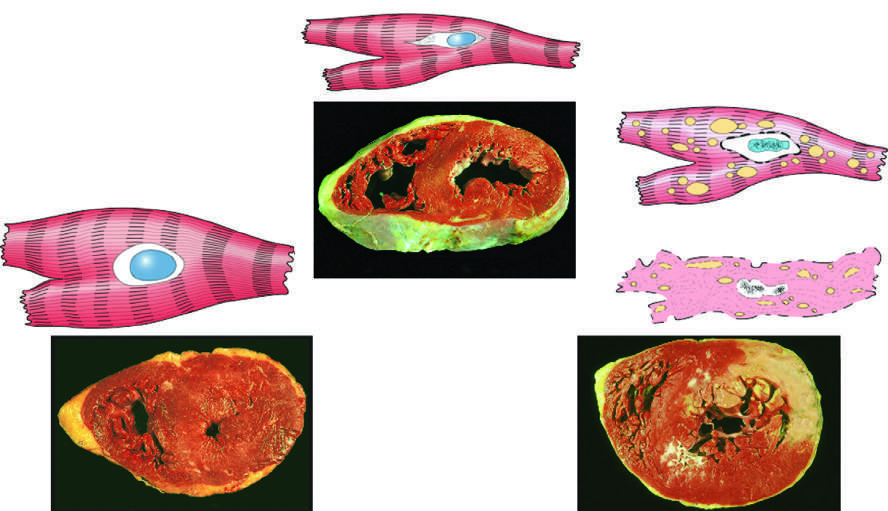does reversible injury represent an acute myocardial infarction in the specimen showing necrosis?
Answer the question using a single word or phrase. No 